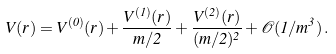Convert formula to latex. <formula><loc_0><loc_0><loc_500><loc_500>V ( r ) = V ^ { ( 0 ) } ( r ) + \frac { V ^ { ( 1 ) } ( r ) } { m / 2 } + \frac { V ^ { ( 2 ) } ( r ) } { ( m / 2 ) ^ { 2 } } + \mathcal { O } ( 1 / m ^ { 3 } ) \, .</formula> 